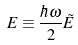Convert formula to latex. <formula><loc_0><loc_0><loc_500><loc_500>E \equiv \frac { \hbar { \omega } } { 2 } \tilde { E }</formula> 